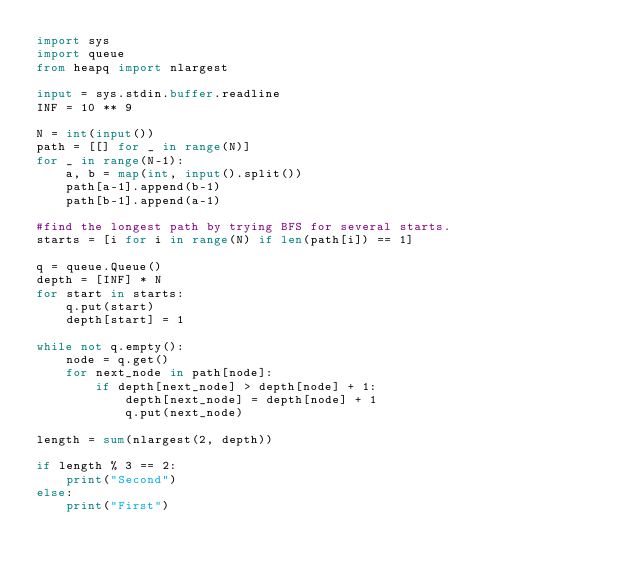<code> <loc_0><loc_0><loc_500><loc_500><_Python_>import sys
import queue
from heapq import nlargest

input = sys.stdin.buffer.readline
INF = 10 ** 9

N = int(input())
path = [[] for _ in range(N)]
for _ in range(N-1):
    a, b = map(int, input().split())
    path[a-1].append(b-1)
    path[b-1].append(a-1)

#find the longest path by trying BFS for several starts.
starts = [i for i in range(N) if len(path[i]) == 1]

q = queue.Queue()
depth = [INF] * N
for start in starts:
    q.put(start)
    depth[start] = 1

while not q.empty():
    node = q.get()
    for next_node in path[node]:
        if depth[next_node] > depth[node] + 1:
            depth[next_node] = depth[node] + 1
            q.put(next_node)
        
length = sum(nlargest(2, depth))

if length % 3 == 2:
    print("Second")
else:
    print("First")</code> 